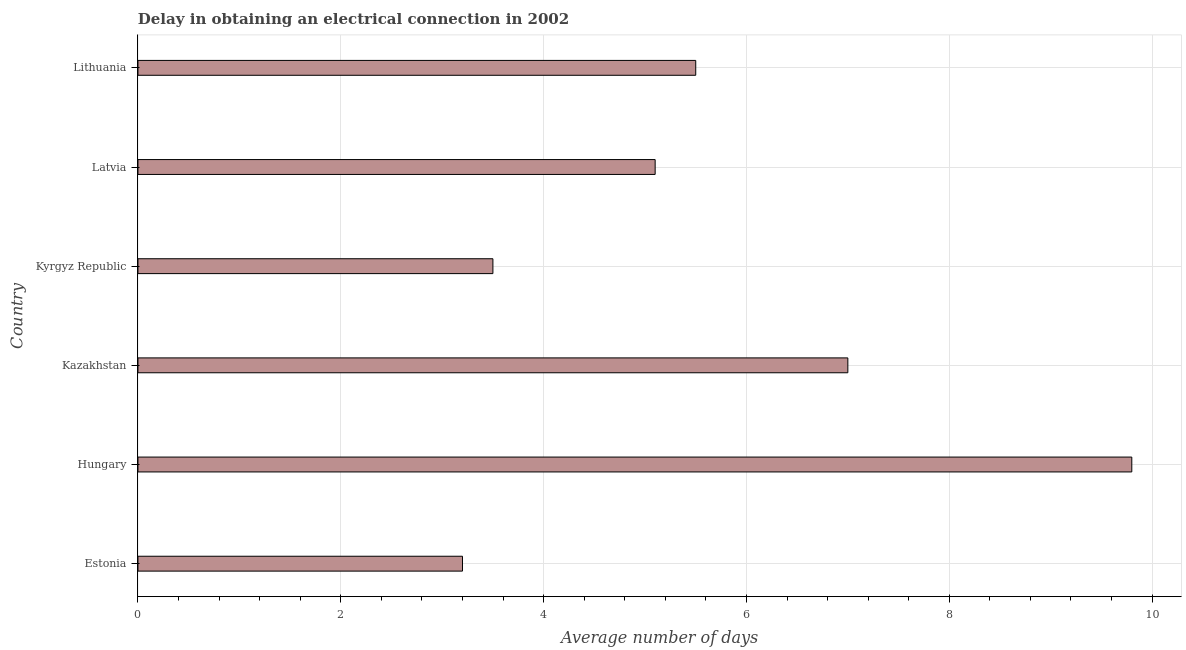Does the graph contain any zero values?
Your answer should be compact. No. Does the graph contain grids?
Ensure brevity in your answer.  Yes. What is the title of the graph?
Your answer should be compact. Delay in obtaining an electrical connection in 2002. What is the label or title of the X-axis?
Keep it short and to the point. Average number of days. What is the dalay in electrical connection in Latvia?
Keep it short and to the point. 5.1. Across all countries, what is the maximum dalay in electrical connection?
Your answer should be compact. 9.8. Across all countries, what is the minimum dalay in electrical connection?
Keep it short and to the point. 3.2. In which country was the dalay in electrical connection maximum?
Keep it short and to the point. Hungary. In which country was the dalay in electrical connection minimum?
Make the answer very short. Estonia. What is the sum of the dalay in electrical connection?
Provide a short and direct response. 34.1. What is the average dalay in electrical connection per country?
Provide a short and direct response. 5.68. What is the ratio of the dalay in electrical connection in Estonia to that in Hungary?
Provide a succinct answer. 0.33. Is the dalay in electrical connection in Estonia less than that in Kazakhstan?
Provide a succinct answer. Yes. Is the sum of the dalay in electrical connection in Estonia and Kazakhstan greater than the maximum dalay in electrical connection across all countries?
Provide a short and direct response. Yes. What is the difference between the highest and the lowest dalay in electrical connection?
Your response must be concise. 6.6. In how many countries, is the dalay in electrical connection greater than the average dalay in electrical connection taken over all countries?
Give a very brief answer. 2. Are all the bars in the graph horizontal?
Provide a succinct answer. Yes. How many countries are there in the graph?
Provide a succinct answer. 6. What is the Average number of days in Estonia?
Make the answer very short. 3.2. What is the Average number of days of Kyrgyz Republic?
Your answer should be compact. 3.5. What is the Average number of days in Lithuania?
Your response must be concise. 5.5. What is the difference between the Average number of days in Estonia and Kazakhstan?
Ensure brevity in your answer.  -3.8. What is the difference between the Average number of days in Estonia and Lithuania?
Offer a very short reply. -2.3. What is the difference between the Average number of days in Hungary and Kyrgyz Republic?
Provide a short and direct response. 6.3. What is the difference between the Average number of days in Hungary and Latvia?
Your response must be concise. 4.7. What is the difference between the Average number of days in Hungary and Lithuania?
Keep it short and to the point. 4.3. What is the difference between the Average number of days in Kyrgyz Republic and Latvia?
Offer a terse response. -1.6. What is the ratio of the Average number of days in Estonia to that in Hungary?
Make the answer very short. 0.33. What is the ratio of the Average number of days in Estonia to that in Kazakhstan?
Keep it short and to the point. 0.46. What is the ratio of the Average number of days in Estonia to that in Kyrgyz Republic?
Offer a terse response. 0.91. What is the ratio of the Average number of days in Estonia to that in Latvia?
Provide a short and direct response. 0.63. What is the ratio of the Average number of days in Estonia to that in Lithuania?
Make the answer very short. 0.58. What is the ratio of the Average number of days in Hungary to that in Latvia?
Make the answer very short. 1.92. What is the ratio of the Average number of days in Hungary to that in Lithuania?
Your answer should be very brief. 1.78. What is the ratio of the Average number of days in Kazakhstan to that in Kyrgyz Republic?
Make the answer very short. 2. What is the ratio of the Average number of days in Kazakhstan to that in Latvia?
Ensure brevity in your answer.  1.37. What is the ratio of the Average number of days in Kazakhstan to that in Lithuania?
Provide a short and direct response. 1.27. What is the ratio of the Average number of days in Kyrgyz Republic to that in Latvia?
Keep it short and to the point. 0.69. What is the ratio of the Average number of days in Kyrgyz Republic to that in Lithuania?
Give a very brief answer. 0.64. What is the ratio of the Average number of days in Latvia to that in Lithuania?
Provide a short and direct response. 0.93. 